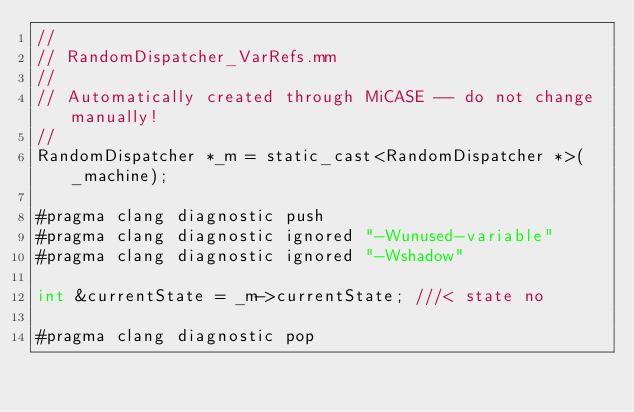<code> <loc_0><loc_0><loc_500><loc_500><_ObjectiveC_>//
// RandomDispatcher_VarRefs.mm
//
// Automatically created through MiCASE -- do not change manually!
//
RandomDispatcher *_m = static_cast<RandomDispatcher *>(_machine);

#pragma clang diagnostic push
#pragma clang diagnostic ignored "-Wunused-variable"
#pragma clang diagnostic ignored "-Wshadow"

int	&currentState = _m->currentState;	///< state no

#pragma clang diagnostic pop
</code> 